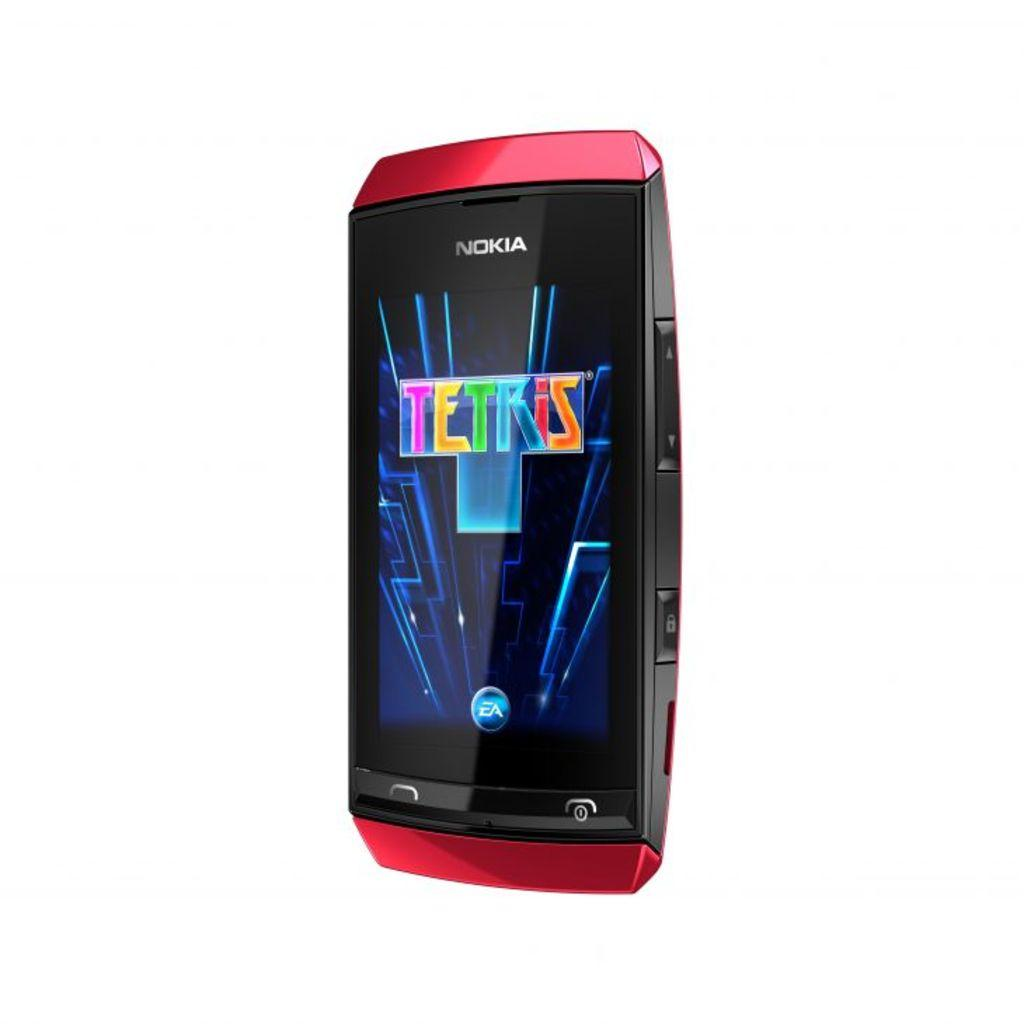<image>
Write a terse but informative summary of the picture. A Nokia cell phone has the game tetris on it. 